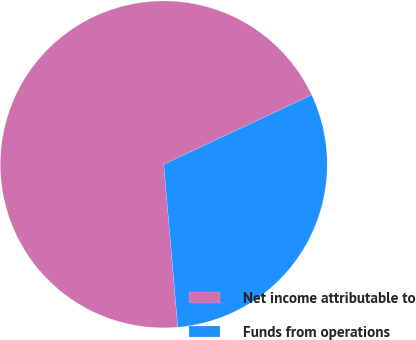<chart> <loc_0><loc_0><loc_500><loc_500><pie_chart><fcel>Net income attributable to<fcel>Funds from operations<nl><fcel>69.39%<fcel>30.61%<nl></chart> 